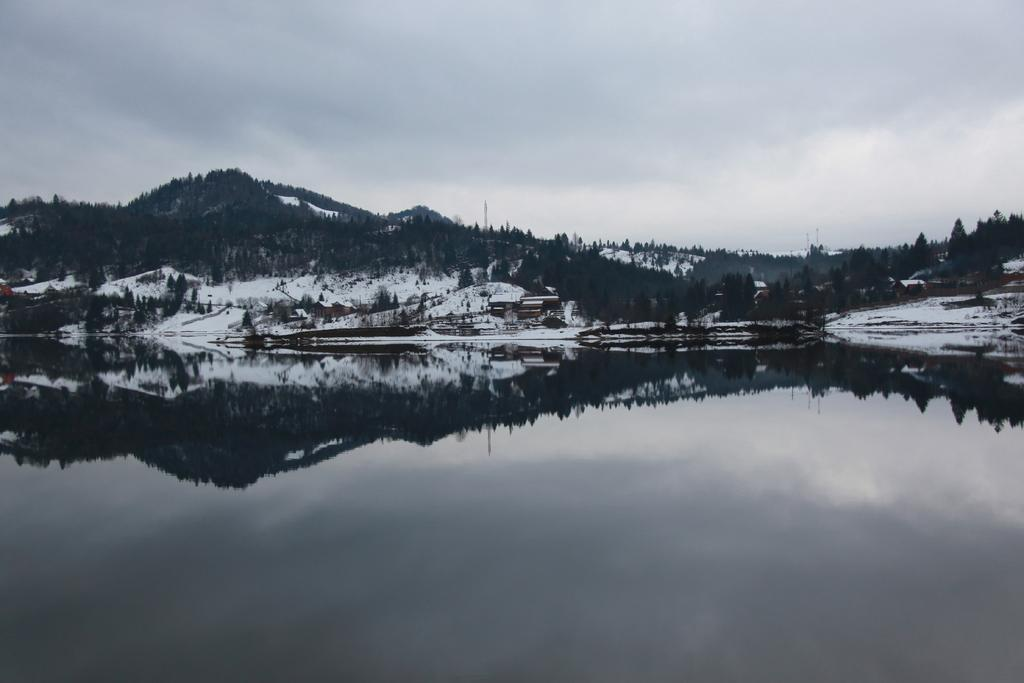What is present in the image that is not solid? There is water visible in the image. What can be seen in the background of the image? There are poles in the background of the image. What type of precipitation is present in the image? There is snow in the image, described as white in color. What type of vegetation is present in the image? There are trees in the image, described as green in color. What is visible in the sky in the image? The sky is visible in the image, described as white and gray in color. What type of wood is used to make the moon in the image? There is no moon present in the image, and therefore no wood is used to make it. How many drops of water can be seen falling from the sky in the image? There is no rain or water droplets visible in the image; only snow is present. 